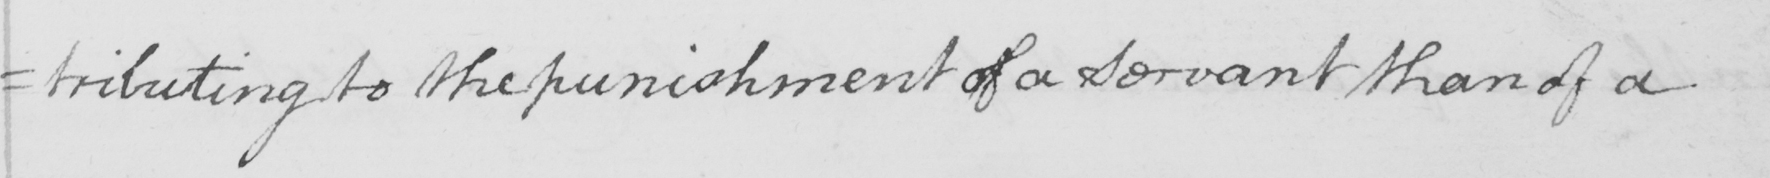Please provide the text content of this handwritten line. =tributing to the punishment of a servant than of a 